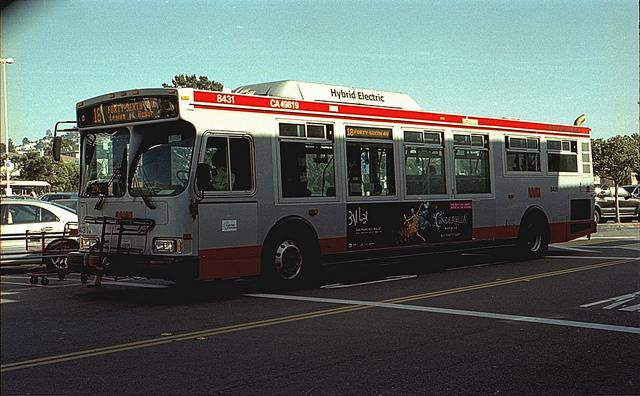How many wheels are visible on the large vehicle? Please explain your reasoning. two. The bus has two wheels seen on the left side. 